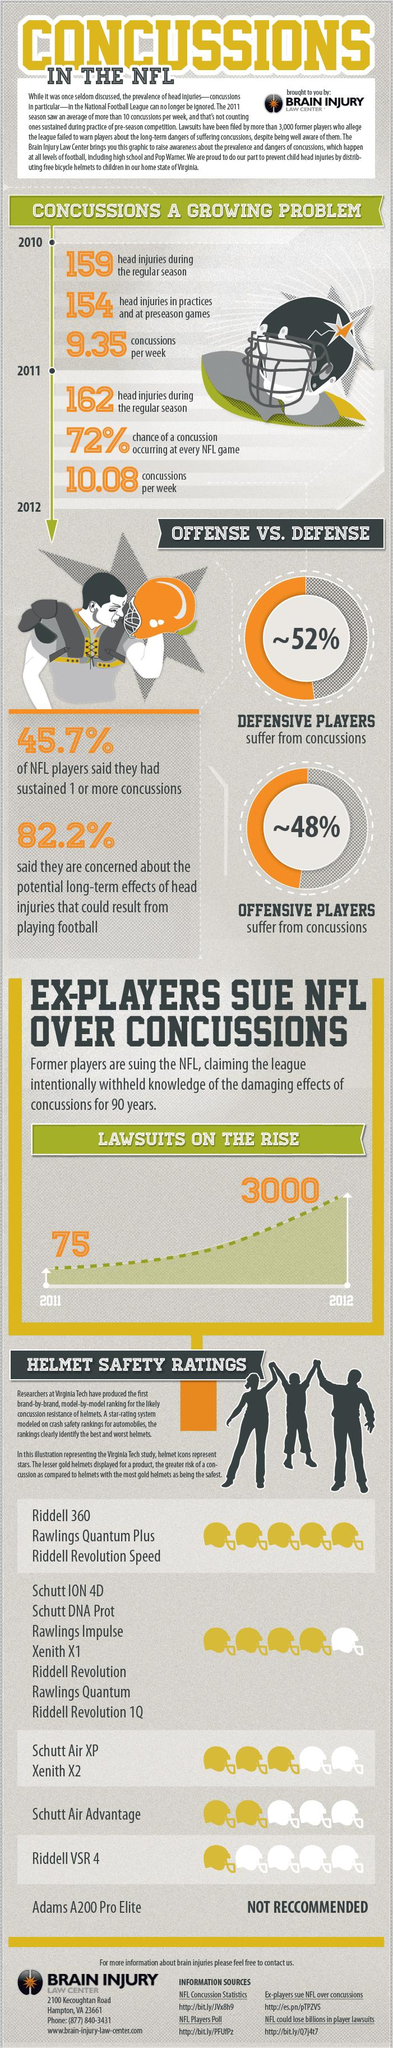Indicate a few pertinent items in this graphic. The safety rating for the Riddell VSR 4 helmet is 4 out of 5. The safety rating for the Schutt Air XP Xenith X2 helmet is 3 out of 5. During the regular seasons of 2010 and 2011, a combined total of 321 head injuries were reported. The safety helmet rating list provides 6 different types of helmets. Defensive players are more likely to suffer from concussions than offensive players. 